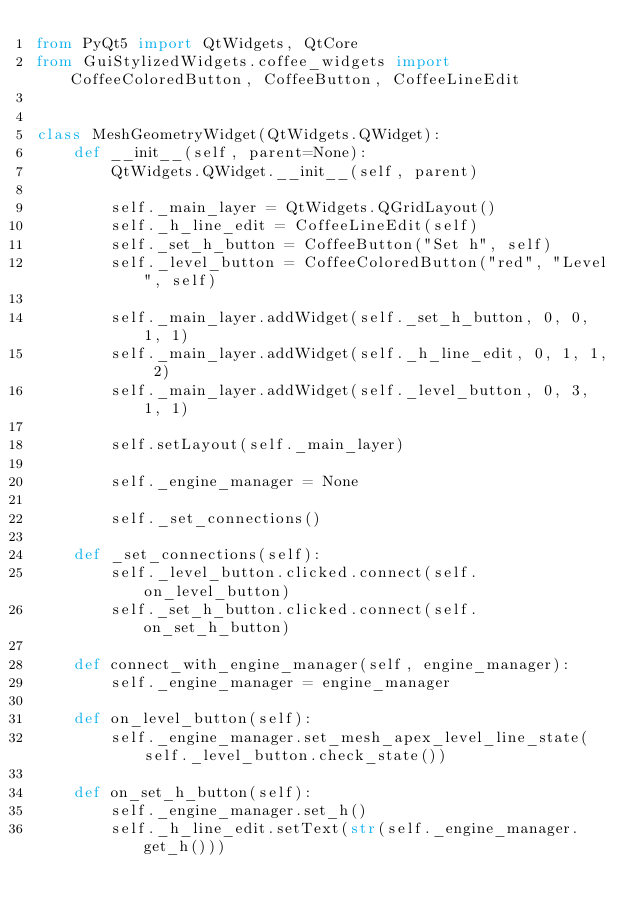<code> <loc_0><loc_0><loc_500><loc_500><_Python_>from PyQt5 import QtWidgets, QtCore
from GuiStylizedWidgets.coffee_widgets import CoffeeColoredButton, CoffeeButton, CoffeeLineEdit


class MeshGeometryWidget(QtWidgets.QWidget):
    def __init__(self, parent=None):
        QtWidgets.QWidget.__init__(self, parent)

        self._main_layer = QtWidgets.QGridLayout()
        self._h_line_edit = CoffeeLineEdit(self)
        self._set_h_button = CoffeeButton("Set h", self)
        self._level_button = CoffeeColoredButton("red", "Level", self)

        self._main_layer.addWidget(self._set_h_button, 0, 0, 1, 1)
        self._main_layer.addWidget(self._h_line_edit, 0, 1, 1, 2)
        self._main_layer.addWidget(self._level_button, 0, 3, 1, 1)

        self.setLayout(self._main_layer)

        self._engine_manager = None

        self._set_connections()

    def _set_connections(self):
        self._level_button.clicked.connect(self.on_level_button)
        self._set_h_button.clicked.connect(self.on_set_h_button)

    def connect_with_engine_manager(self, engine_manager):
        self._engine_manager = engine_manager

    def on_level_button(self):
        self._engine_manager.set_mesh_apex_level_line_state(self._level_button.check_state())

    def on_set_h_button(self):
        self._engine_manager.set_h()
        self._h_line_edit.setText(str(self._engine_manager.get_h()))
</code> 